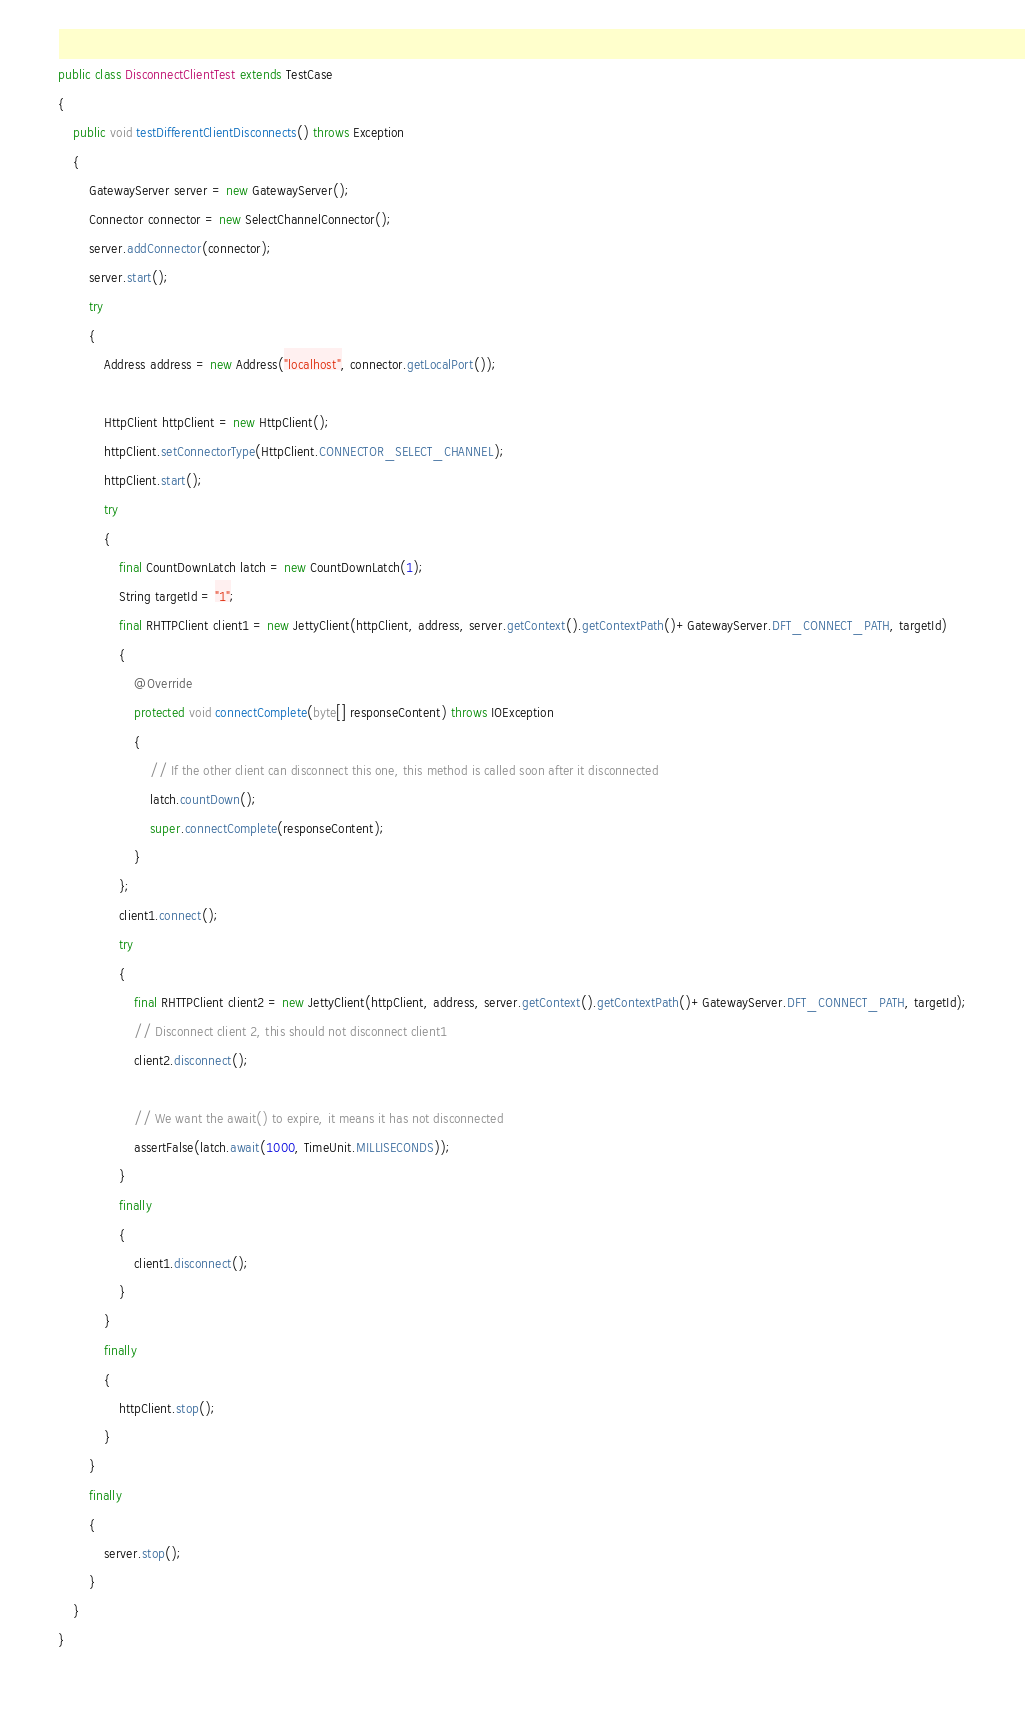<code> <loc_0><loc_0><loc_500><loc_500><_Java_>public class DisconnectClientTest extends TestCase
{
    public void testDifferentClientDisconnects() throws Exception
    {
        GatewayServer server = new GatewayServer();
        Connector connector = new SelectChannelConnector();
        server.addConnector(connector);
        server.start();
        try
        {
            Address address = new Address("localhost", connector.getLocalPort());

            HttpClient httpClient = new HttpClient();
            httpClient.setConnectorType(HttpClient.CONNECTOR_SELECT_CHANNEL);
            httpClient.start();
            try
            {
                final CountDownLatch latch = new CountDownLatch(1);
                String targetId = "1";
                final RHTTPClient client1 = new JettyClient(httpClient, address, server.getContext().getContextPath()+GatewayServer.DFT_CONNECT_PATH, targetId)
                {
                    @Override
                    protected void connectComplete(byte[] responseContent) throws IOException
                    {
                        // If the other client can disconnect this one, this method is called soon after it disconnected
                        latch.countDown();
                        super.connectComplete(responseContent);
                    }
                };
                client1.connect();
                try
                {
                    final RHTTPClient client2 = new JettyClient(httpClient, address, server.getContext().getContextPath()+GatewayServer.DFT_CONNECT_PATH, targetId);
                    // Disconnect client 2, this should not disconnect client1
                    client2.disconnect();

                    // We want the await() to expire, it means it has not disconnected
                    assertFalse(latch.await(1000, TimeUnit.MILLISECONDS));
                }
                finally
                {
                    client1.disconnect();
                }
            }
            finally
            {
                httpClient.stop();
            }
        }
        finally
        {
            server.stop();
        }
    }
}
</code> 